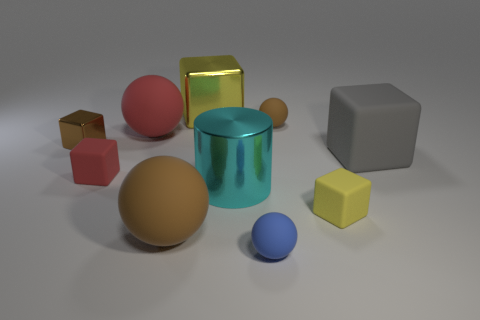What material is the yellow object that is right of the large cyan cylinder?
Your answer should be very brief. Rubber. What number of things are either matte objects in front of the small brown shiny object or red objects that are behind the gray matte thing?
Provide a short and direct response. 6. There is another big thing that is the same shape as the big yellow object; what is its material?
Give a very brief answer. Rubber. Do the large ball that is to the right of the big red rubber sphere and the small matte ball in front of the large cyan thing have the same color?
Your answer should be compact. No. Is there a brown ball of the same size as the cyan thing?
Offer a terse response. Yes. There is a ball that is both right of the big shiny cylinder and in front of the big matte cube; what is it made of?
Your answer should be very brief. Rubber. How many rubber things are small brown blocks or tiny red blocks?
Offer a terse response. 1. There is a small brown thing that is made of the same material as the blue ball; what shape is it?
Keep it short and to the point. Sphere. How many small rubber objects are to the left of the small yellow rubber block and in front of the shiny cylinder?
Provide a short and direct response. 1. Are there any other things that have the same shape as the yellow rubber thing?
Your answer should be very brief. Yes. 